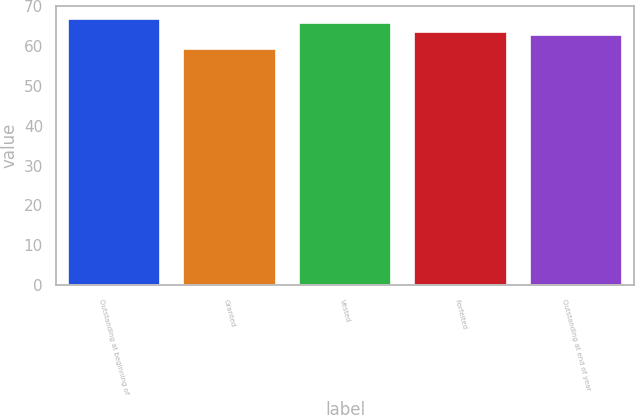<chart> <loc_0><loc_0><loc_500><loc_500><bar_chart><fcel>Outstanding at beginning of<fcel>Granted<fcel>Vested<fcel>Forfeited<fcel>Outstanding at end of year<nl><fcel>66.76<fcel>59.34<fcel>65.77<fcel>63.56<fcel>62.82<nl></chart> 